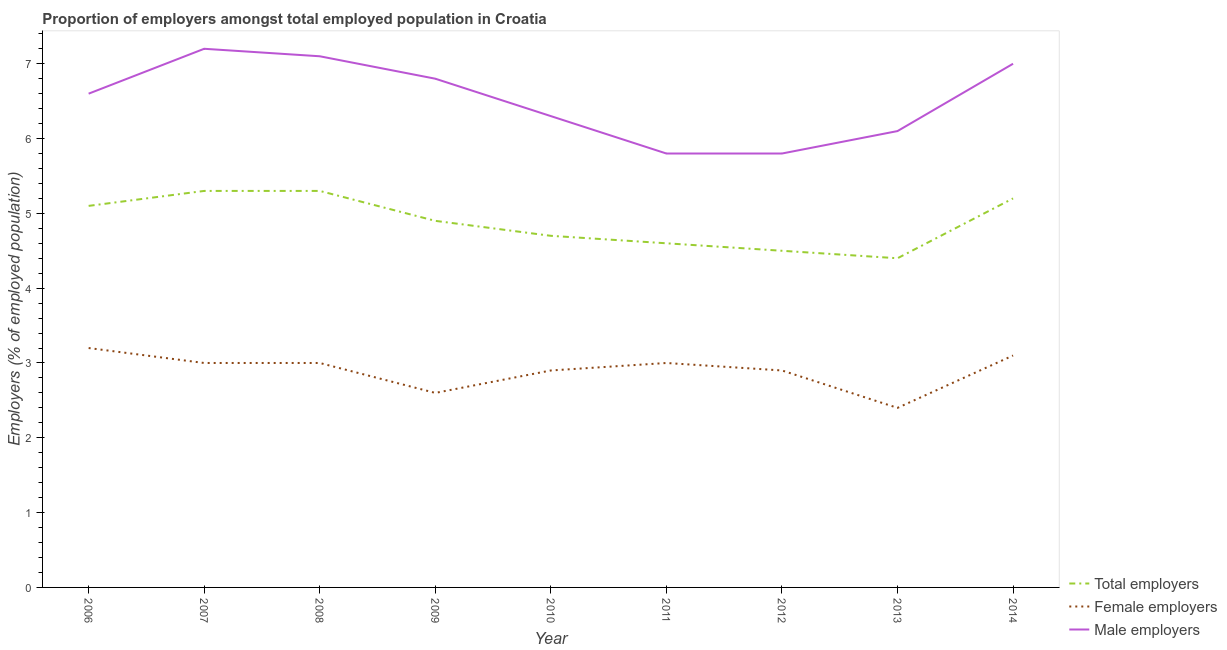How many different coloured lines are there?
Provide a short and direct response. 3. What is the percentage of male employers in 2014?
Make the answer very short. 7. Across all years, what is the maximum percentage of male employers?
Offer a terse response. 7.2. Across all years, what is the minimum percentage of total employers?
Your response must be concise. 4.4. In which year was the percentage of total employers minimum?
Offer a very short reply. 2013. What is the total percentage of total employers in the graph?
Your answer should be compact. 44. What is the difference between the percentage of female employers in 2009 and that in 2012?
Give a very brief answer. -0.3. What is the difference between the percentage of female employers in 2010 and the percentage of total employers in 2008?
Keep it short and to the point. -2.4. What is the average percentage of female employers per year?
Offer a terse response. 2.9. In the year 2007, what is the difference between the percentage of male employers and percentage of female employers?
Ensure brevity in your answer.  4.2. In how many years, is the percentage of female employers greater than 3.2 %?
Ensure brevity in your answer.  1. What is the ratio of the percentage of male employers in 2008 to that in 2012?
Your answer should be compact. 1.22. Is the difference between the percentage of female employers in 2008 and 2010 greater than the difference between the percentage of total employers in 2008 and 2010?
Make the answer very short. No. What is the difference between the highest and the second highest percentage of male employers?
Provide a short and direct response. 0.1. What is the difference between the highest and the lowest percentage of total employers?
Provide a succinct answer. 0.9. Is the sum of the percentage of total employers in 2009 and 2011 greater than the maximum percentage of male employers across all years?
Your response must be concise. Yes. Does the percentage of female employers monotonically increase over the years?
Your answer should be compact. No. Is the percentage of male employers strictly less than the percentage of total employers over the years?
Ensure brevity in your answer.  No. What is the difference between two consecutive major ticks on the Y-axis?
Your answer should be compact. 1. Are the values on the major ticks of Y-axis written in scientific E-notation?
Offer a very short reply. No. How many legend labels are there?
Ensure brevity in your answer.  3. How are the legend labels stacked?
Offer a very short reply. Vertical. What is the title of the graph?
Provide a short and direct response. Proportion of employers amongst total employed population in Croatia. Does "Machinery" appear as one of the legend labels in the graph?
Your response must be concise. No. What is the label or title of the Y-axis?
Give a very brief answer. Employers (% of employed population). What is the Employers (% of employed population) of Total employers in 2006?
Your answer should be compact. 5.1. What is the Employers (% of employed population) in Female employers in 2006?
Your response must be concise. 3.2. What is the Employers (% of employed population) of Male employers in 2006?
Make the answer very short. 6.6. What is the Employers (% of employed population) of Total employers in 2007?
Keep it short and to the point. 5.3. What is the Employers (% of employed population) in Female employers in 2007?
Your answer should be very brief. 3. What is the Employers (% of employed population) of Male employers in 2007?
Offer a very short reply. 7.2. What is the Employers (% of employed population) of Total employers in 2008?
Provide a short and direct response. 5.3. What is the Employers (% of employed population) in Female employers in 2008?
Your answer should be very brief. 3. What is the Employers (% of employed population) of Male employers in 2008?
Your answer should be very brief. 7.1. What is the Employers (% of employed population) of Total employers in 2009?
Provide a short and direct response. 4.9. What is the Employers (% of employed population) of Female employers in 2009?
Offer a terse response. 2.6. What is the Employers (% of employed population) of Male employers in 2009?
Provide a short and direct response. 6.8. What is the Employers (% of employed population) in Total employers in 2010?
Offer a very short reply. 4.7. What is the Employers (% of employed population) of Female employers in 2010?
Offer a very short reply. 2.9. What is the Employers (% of employed population) in Male employers in 2010?
Give a very brief answer. 6.3. What is the Employers (% of employed population) in Total employers in 2011?
Your response must be concise. 4.6. What is the Employers (% of employed population) of Female employers in 2011?
Offer a terse response. 3. What is the Employers (% of employed population) of Male employers in 2011?
Your answer should be very brief. 5.8. What is the Employers (% of employed population) of Total employers in 2012?
Make the answer very short. 4.5. What is the Employers (% of employed population) in Female employers in 2012?
Your answer should be very brief. 2.9. What is the Employers (% of employed population) in Male employers in 2012?
Provide a succinct answer. 5.8. What is the Employers (% of employed population) of Total employers in 2013?
Ensure brevity in your answer.  4.4. What is the Employers (% of employed population) in Female employers in 2013?
Provide a succinct answer. 2.4. What is the Employers (% of employed population) of Male employers in 2013?
Your response must be concise. 6.1. What is the Employers (% of employed population) of Total employers in 2014?
Keep it short and to the point. 5.2. What is the Employers (% of employed population) in Female employers in 2014?
Make the answer very short. 3.1. What is the Employers (% of employed population) in Male employers in 2014?
Keep it short and to the point. 7. Across all years, what is the maximum Employers (% of employed population) of Total employers?
Offer a terse response. 5.3. Across all years, what is the maximum Employers (% of employed population) of Female employers?
Keep it short and to the point. 3.2. Across all years, what is the maximum Employers (% of employed population) of Male employers?
Provide a short and direct response. 7.2. Across all years, what is the minimum Employers (% of employed population) in Total employers?
Provide a succinct answer. 4.4. Across all years, what is the minimum Employers (% of employed population) of Female employers?
Offer a terse response. 2.4. Across all years, what is the minimum Employers (% of employed population) in Male employers?
Keep it short and to the point. 5.8. What is the total Employers (% of employed population) of Female employers in the graph?
Make the answer very short. 26.1. What is the total Employers (% of employed population) in Male employers in the graph?
Your response must be concise. 58.7. What is the difference between the Employers (% of employed population) in Female employers in 2006 and that in 2007?
Make the answer very short. 0.2. What is the difference between the Employers (% of employed population) in Male employers in 2006 and that in 2007?
Make the answer very short. -0.6. What is the difference between the Employers (% of employed population) of Total employers in 2006 and that in 2008?
Make the answer very short. -0.2. What is the difference between the Employers (% of employed population) of Male employers in 2006 and that in 2008?
Offer a very short reply. -0.5. What is the difference between the Employers (% of employed population) of Total employers in 2006 and that in 2009?
Give a very brief answer. 0.2. What is the difference between the Employers (% of employed population) in Total employers in 2006 and that in 2010?
Provide a short and direct response. 0.4. What is the difference between the Employers (% of employed population) of Female employers in 2006 and that in 2010?
Keep it short and to the point. 0.3. What is the difference between the Employers (% of employed population) in Total employers in 2006 and that in 2011?
Provide a short and direct response. 0.5. What is the difference between the Employers (% of employed population) in Total employers in 2006 and that in 2013?
Ensure brevity in your answer.  0.7. What is the difference between the Employers (% of employed population) of Female employers in 2006 and that in 2013?
Your response must be concise. 0.8. What is the difference between the Employers (% of employed population) of Male employers in 2006 and that in 2013?
Your answer should be compact. 0.5. What is the difference between the Employers (% of employed population) of Male employers in 2006 and that in 2014?
Offer a terse response. -0.4. What is the difference between the Employers (% of employed population) in Female employers in 2007 and that in 2008?
Give a very brief answer. 0. What is the difference between the Employers (% of employed population) of Male employers in 2007 and that in 2008?
Provide a succinct answer. 0.1. What is the difference between the Employers (% of employed population) of Male employers in 2007 and that in 2009?
Ensure brevity in your answer.  0.4. What is the difference between the Employers (% of employed population) of Female employers in 2007 and that in 2010?
Your answer should be compact. 0.1. What is the difference between the Employers (% of employed population) of Total employers in 2007 and that in 2011?
Give a very brief answer. 0.7. What is the difference between the Employers (% of employed population) in Female employers in 2007 and that in 2011?
Your response must be concise. 0. What is the difference between the Employers (% of employed population) of Female employers in 2007 and that in 2012?
Give a very brief answer. 0.1. What is the difference between the Employers (% of employed population) of Total employers in 2007 and that in 2013?
Your answer should be very brief. 0.9. What is the difference between the Employers (% of employed population) of Total employers in 2007 and that in 2014?
Ensure brevity in your answer.  0.1. What is the difference between the Employers (% of employed population) in Male employers in 2007 and that in 2014?
Make the answer very short. 0.2. What is the difference between the Employers (% of employed population) of Total employers in 2008 and that in 2010?
Your answer should be compact. 0.6. What is the difference between the Employers (% of employed population) of Female employers in 2008 and that in 2010?
Offer a very short reply. 0.1. What is the difference between the Employers (% of employed population) of Female employers in 2008 and that in 2011?
Provide a succinct answer. 0. What is the difference between the Employers (% of employed population) in Total employers in 2008 and that in 2012?
Give a very brief answer. 0.8. What is the difference between the Employers (% of employed population) of Female employers in 2008 and that in 2012?
Keep it short and to the point. 0.1. What is the difference between the Employers (% of employed population) of Total employers in 2008 and that in 2013?
Offer a terse response. 0.9. What is the difference between the Employers (% of employed population) in Female employers in 2008 and that in 2013?
Give a very brief answer. 0.6. What is the difference between the Employers (% of employed population) in Male employers in 2008 and that in 2013?
Your answer should be very brief. 1. What is the difference between the Employers (% of employed population) in Total employers in 2008 and that in 2014?
Make the answer very short. 0.1. What is the difference between the Employers (% of employed population) of Total employers in 2009 and that in 2010?
Keep it short and to the point. 0.2. What is the difference between the Employers (% of employed population) of Male employers in 2009 and that in 2010?
Your answer should be compact. 0.5. What is the difference between the Employers (% of employed population) in Total employers in 2009 and that in 2011?
Ensure brevity in your answer.  0.3. What is the difference between the Employers (% of employed population) of Total employers in 2009 and that in 2012?
Provide a short and direct response. 0.4. What is the difference between the Employers (% of employed population) of Female employers in 2009 and that in 2012?
Ensure brevity in your answer.  -0.3. What is the difference between the Employers (% of employed population) of Female employers in 2009 and that in 2013?
Your response must be concise. 0.2. What is the difference between the Employers (% of employed population) in Total employers in 2009 and that in 2014?
Your response must be concise. -0.3. What is the difference between the Employers (% of employed population) of Female employers in 2009 and that in 2014?
Offer a terse response. -0.5. What is the difference between the Employers (% of employed population) of Male employers in 2009 and that in 2014?
Ensure brevity in your answer.  -0.2. What is the difference between the Employers (% of employed population) in Total employers in 2010 and that in 2011?
Provide a succinct answer. 0.1. What is the difference between the Employers (% of employed population) in Female employers in 2010 and that in 2011?
Provide a succinct answer. -0.1. What is the difference between the Employers (% of employed population) in Female employers in 2010 and that in 2012?
Your answer should be very brief. 0. What is the difference between the Employers (% of employed population) in Male employers in 2010 and that in 2012?
Ensure brevity in your answer.  0.5. What is the difference between the Employers (% of employed population) in Total employers in 2010 and that in 2014?
Your answer should be very brief. -0.5. What is the difference between the Employers (% of employed population) of Male employers in 2011 and that in 2014?
Your response must be concise. -1.2. What is the difference between the Employers (% of employed population) in Total employers in 2012 and that in 2013?
Offer a very short reply. 0.1. What is the difference between the Employers (% of employed population) in Female employers in 2012 and that in 2013?
Your answer should be compact. 0.5. What is the difference between the Employers (% of employed population) of Male employers in 2013 and that in 2014?
Offer a terse response. -0.9. What is the difference between the Employers (% of employed population) in Total employers in 2006 and the Employers (% of employed population) in Female employers in 2007?
Provide a succinct answer. 2.1. What is the difference between the Employers (% of employed population) of Total employers in 2006 and the Employers (% of employed population) of Male employers in 2007?
Your answer should be compact. -2.1. What is the difference between the Employers (% of employed population) in Female employers in 2006 and the Employers (% of employed population) in Male employers in 2007?
Offer a terse response. -4. What is the difference between the Employers (% of employed population) of Total employers in 2006 and the Employers (% of employed population) of Female employers in 2008?
Your answer should be very brief. 2.1. What is the difference between the Employers (% of employed population) of Total employers in 2006 and the Employers (% of employed population) of Male employers in 2008?
Give a very brief answer. -2. What is the difference between the Employers (% of employed population) of Total employers in 2006 and the Employers (% of employed population) of Female employers in 2009?
Make the answer very short. 2.5. What is the difference between the Employers (% of employed population) in Total employers in 2006 and the Employers (% of employed population) in Female employers in 2010?
Make the answer very short. 2.2. What is the difference between the Employers (% of employed population) in Female employers in 2006 and the Employers (% of employed population) in Male employers in 2011?
Keep it short and to the point. -2.6. What is the difference between the Employers (% of employed population) of Total employers in 2006 and the Employers (% of employed population) of Female employers in 2012?
Your response must be concise. 2.2. What is the difference between the Employers (% of employed population) in Total employers in 2006 and the Employers (% of employed population) in Female employers in 2013?
Your answer should be very brief. 2.7. What is the difference between the Employers (% of employed population) of Female employers in 2006 and the Employers (% of employed population) of Male employers in 2013?
Your answer should be very brief. -2.9. What is the difference between the Employers (% of employed population) of Total employers in 2006 and the Employers (% of employed population) of Female employers in 2014?
Offer a terse response. 2. What is the difference between the Employers (% of employed population) of Total employers in 2006 and the Employers (% of employed population) of Male employers in 2014?
Ensure brevity in your answer.  -1.9. What is the difference between the Employers (% of employed population) in Total employers in 2007 and the Employers (% of employed population) in Male employers in 2008?
Offer a terse response. -1.8. What is the difference between the Employers (% of employed population) of Female employers in 2007 and the Employers (% of employed population) of Male employers in 2008?
Make the answer very short. -4.1. What is the difference between the Employers (% of employed population) in Total employers in 2007 and the Employers (% of employed population) in Male employers in 2009?
Offer a terse response. -1.5. What is the difference between the Employers (% of employed population) of Total employers in 2007 and the Employers (% of employed population) of Female employers in 2011?
Offer a terse response. 2.3. What is the difference between the Employers (% of employed population) in Female employers in 2007 and the Employers (% of employed population) in Male employers in 2011?
Ensure brevity in your answer.  -2.8. What is the difference between the Employers (% of employed population) of Female employers in 2007 and the Employers (% of employed population) of Male employers in 2012?
Give a very brief answer. -2.8. What is the difference between the Employers (% of employed population) in Total employers in 2007 and the Employers (% of employed population) in Female employers in 2013?
Your answer should be compact. 2.9. What is the difference between the Employers (% of employed population) of Total employers in 2007 and the Employers (% of employed population) of Male employers in 2014?
Your answer should be compact. -1.7. What is the difference between the Employers (% of employed population) of Female employers in 2007 and the Employers (% of employed population) of Male employers in 2014?
Keep it short and to the point. -4. What is the difference between the Employers (% of employed population) in Female employers in 2008 and the Employers (% of employed population) in Male employers in 2009?
Ensure brevity in your answer.  -3.8. What is the difference between the Employers (% of employed population) in Total employers in 2008 and the Employers (% of employed population) in Female employers in 2010?
Your answer should be compact. 2.4. What is the difference between the Employers (% of employed population) in Female employers in 2008 and the Employers (% of employed population) in Male employers in 2010?
Provide a succinct answer. -3.3. What is the difference between the Employers (% of employed population) of Total employers in 2008 and the Employers (% of employed population) of Female employers in 2011?
Provide a short and direct response. 2.3. What is the difference between the Employers (% of employed population) in Total employers in 2008 and the Employers (% of employed population) in Female employers in 2012?
Offer a very short reply. 2.4. What is the difference between the Employers (% of employed population) of Total employers in 2008 and the Employers (% of employed population) of Female employers in 2013?
Offer a very short reply. 2.9. What is the difference between the Employers (% of employed population) of Total employers in 2008 and the Employers (% of employed population) of Male employers in 2013?
Offer a terse response. -0.8. What is the difference between the Employers (% of employed population) of Female employers in 2008 and the Employers (% of employed population) of Male employers in 2013?
Ensure brevity in your answer.  -3.1. What is the difference between the Employers (% of employed population) in Total employers in 2008 and the Employers (% of employed population) in Male employers in 2014?
Provide a succinct answer. -1.7. What is the difference between the Employers (% of employed population) in Female employers in 2008 and the Employers (% of employed population) in Male employers in 2014?
Make the answer very short. -4. What is the difference between the Employers (% of employed population) of Female employers in 2009 and the Employers (% of employed population) of Male employers in 2010?
Give a very brief answer. -3.7. What is the difference between the Employers (% of employed population) in Total employers in 2009 and the Employers (% of employed population) in Female employers in 2011?
Give a very brief answer. 1.9. What is the difference between the Employers (% of employed population) in Female employers in 2009 and the Employers (% of employed population) in Male employers in 2011?
Your answer should be very brief. -3.2. What is the difference between the Employers (% of employed population) of Total employers in 2009 and the Employers (% of employed population) of Male employers in 2012?
Ensure brevity in your answer.  -0.9. What is the difference between the Employers (% of employed population) of Female employers in 2009 and the Employers (% of employed population) of Male employers in 2012?
Keep it short and to the point. -3.2. What is the difference between the Employers (% of employed population) of Total employers in 2009 and the Employers (% of employed population) of Female employers in 2013?
Keep it short and to the point. 2.5. What is the difference between the Employers (% of employed population) of Female employers in 2009 and the Employers (% of employed population) of Male employers in 2013?
Provide a succinct answer. -3.5. What is the difference between the Employers (% of employed population) of Total employers in 2009 and the Employers (% of employed population) of Male employers in 2014?
Provide a succinct answer. -2.1. What is the difference between the Employers (% of employed population) in Female employers in 2010 and the Employers (% of employed population) in Male employers in 2011?
Your response must be concise. -2.9. What is the difference between the Employers (% of employed population) of Total employers in 2010 and the Employers (% of employed population) of Male employers in 2012?
Your response must be concise. -1.1. What is the difference between the Employers (% of employed population) of Female employers in 2010 and the Employers (% of employed population) of Male employers in 2012?
Provide a short and direct response. -2.9. What is the difference between the Employers (% of employed population) in Total employers in 2010 and the Employers (% of employed population) in Female employers in 2013?
Offer a terse response. 2.3. What is the difference between the Employers (% of employed population) of Total employers in 2010 and the Employers (% of employed population) of Female employers in 2014?
Give a very brief answer. 1.6. What is the difference between the Employers (% of employed population) in Female employers in 2010 and the Employers (% of employed population) in Male employers in 2014?
Make the answer very short. -4.1. What is the difference between the Employers (% of employed population) in Total employers in 2011 and the Employers (% of employed population) in Female employers in 2012?
Provide a succinct answer. 1.7. What is the difference between the Employers (% of employed population) of Female employers in 2011 and the Employers (% of employed population) of Male employers in 2012?
Keep it short and to the point. -2.8. What is the difference between the Employers (% of employed population) in Total employers in 2011 and the Employers (% of employed population) in Female employers in 2013?
Offer a terse response. 2.2. What is the difference between the Employers (% of employed population) in Female employers in 2011 and the Employers (% of employed population) in Male employers in 2013?
Offer a terse response. -3.1. What is the difference between the Employers (% of employed population) in Female employers in 2011 and the Employers (% of employed population) in Male employers in 2014?
Give a very brief answer. -4. What is the difference between the Employers (% of employed population) in Total employers in 2012 and the Employers (% of employed population) in Male employers in 2013?
Provide a succinct answer. -1.6. What is the difference between the Employers (% of employed population) in Female employers in 2012 and the Employers (% of employed population) in Male employers in 2013?
Provide a short and direct response. -3.2. What is the difference between the Employers (% of employed population) of Total employers in 2012 and the Employers (% of employed population) of Female employers in 2014?
Your answer should be compact. 1.4. What is the difference between the Employers (% of employed population) of Total employers in 2012 and the Employers (% of employed population) of Male employers in 2014?
Your answer should be compact. -2.5. What is the difference between the Employers (% of employed population) in Total employers in 2013 and the Employers (% of employed population) in Male employers in 2014?
Offer a very short reply. -2.6. What is the average Employers (% of employed population) of Total employers per year?
Your answer should be very brief. 4.89. What is the average Employers (% of employed population) in Male employers per year?
Offer a very short reply. 6.52. In the year 2007, what is the difference between the Employers (% of employed population) in Total employers and Employers (% of employed population) in Female employers?
Your answer should be compact. 2.3. In the year 2007, what is the difference between the Employers (% of employed population) of Total employers and Employers (% of employed population) of Male employers?
Give a very brief answer. -1.9. In the year 2007, what is the difference between the Employers (% of employed population) of Female employers and Employers (% of employed population) of Male employers?
Provide a succinct answer. -4.2. In the year 2009, what is the difference between the Employers (% of employed population) of Total employers and Employers (% of employed population) of Female employers?
Offer a very short reply. 2.3. In the year 2010, what is the difference between the Employers (% of employed population) in Total employers and Employers (% of employed population) in Female employers?
Make the answer very short. 1.8. In the year 2010, what is the difference between the Employers (% of employed population) in Total employers and Employers (% of employed population) in Male employers?
Ensure brevity in your answer.  -1.6. In the year 2011, what is the difference between the Employers (% of employed population) of Total employers and Employers (% of employed population) of Male employers?
Keep it short and to the point. -1.2. In the year 2013, what is the difference between the Employers (% of employed population) of Total employers and Employers (% of employed population) of Female employers?
Your answer should be compact. 2. In the year 2013, what is the difference between the Employers (% of employed population) in Total employers and Employers (% of employed population) in Male employers?
Offer a very short reply. -1.7. In the year 2014, what is the difference between the Employers (% of employed population) of Total employers and Employers (% of employed population) of Male employers?
Your answer should be very brief. -1.8. In the year 2014, what is the difference between the Employers (% of employed population) of Female employers and Employers (% of employed population) of Male employers?
Provide a succinct answer. -3.9. What is the ratio of the Employers (% of employed population) in Total employers in 2006 to that in 2007?
Provide a short and direct response. 0.96. What is the ratio of the Employers (% of employed population) of Female employers in 2006 to that in 2007?
Make the answer very short. 1.07. What is the ratio of the Employers (% of employed population) in Total employers in 2006 to that in 2008?
Offer a terse response. 0.96. What is the ratio of the Employers (% of employed population) of Female employers in 2006 to that in 2008?
Ensure brevity in your answer.  1.07. What is the ratio of the Employers (% of employed population) in Male employers in 2006 to that in 2008?
Your response must be concise. 0.93. What is the ratio of the Employers (% of employed population) in Total employers in 2006 to that in 2009?
Ensure brevity in your answer.  1.04. What is the ratio of the Employers (% of employed population) in Female employers in 2006 to that in 2009?
Give a very brief answer. 1.23. What is the ratio of the Employers (% of employed population) in Male employers in 2006 to that in 2009?
Your answer should be very brief. 0.97. What is the ratio of the Employers (% of employed population) of Total employers in 2006 to that in 2010?
Offer a terse response. 1.09. What is the ratio of the Employers (% of employed population) of Female employers in 2006 to that in 2010?
Provide a succinct answer. 1.1. What is the ratio of the Employers (% of employed population) of Male employers in 2006 to that in 2010?
Make the answer very short. 1.05. What is the ratio of the Employers (% of employed population) of Total employers in 2006 to that in 2011?
Provide a short and direct response. 1.11. What is the ratio of the Employers (% of employed population) in Female employers in 2006 to that in 2011?
Give a very brief answer. 1.07. What is the ratio of the Employers (% of employed population) in Male employers in 2006 to that in 2011?
Provide a short and direct response. 1.14. What is the ratio of the Employers (% of employed population) in Total employers in 2006 to that in 2012?
Ensure brevity in your answer.  1.13. What is the ratio of the Employers (% of employed population) in Female employers in 2006 to that in 2012?
Make the answer very short. 1.1. What is the ratio of the Employers (% of employed population) of Male employers in 2006 to that in 2012?
Ensure brevity in your answer.  1.14. What is the ratio of the Employers (% of employed population) of Total employers in 2006 to that in 2013?
Offer a very short reply. 1.16. What is the ratio of the Employers (% of employed population) in Male employers in 2006 to that in 2013?
Make the answer very short. 1.08. What is the ratio of the Employers (% of employed population) in Total employers in 2006 to that in 2014?
Keep it short and to the point. 0.98. What is the ratio of the Employers (% of employed population) in Female employers in 2006 to that in 2014?
Your answer should be very brief. 1.03. What is the ratio of the Employers (% of employed population) in Male employers in 2006 to that in 2014?
Your answer should be very brief. 0.94. What is the ratio of the Employers (% of employed population) of Total employers in 2007 to that in 2008?
Your answer should be compact. 1. What is the ratio of the Employers (% of employed population) in Female employers in 2007 to that in 2008?
Your response must be concise. 1. What is the ratio of the Employers (% of employed population) in Male employers in 2007 to that in 2008?
Ensure brevity in your answer.  1.01. What is the ratio of the Employers (% of employed population) in Total employers in 2007 to that in 2009?
Offer a very short reply. 1.08. What is the ratio of the Employers (% of employed population) of Female employers in 2007 to that in 2009?
Provide a succinct answer. 1.15. What is the ratio of the Employers (% of employed population) in Male employers in 2007 to that in 2009?
Your answer should be compact. 1.06. What is the ratio of the Employers (% of employed population) of Total employers in 2007 to that in 2010?
Keep it short and to the point. 1.13. What is the ratio of the Employers (% of employed population) of Female employers in 2007 to that in 2010?
Your response must be concise. 1.03. What is the ratio of the Employers (% of employed population) in Male employers in 2007 to that in 2010?
Offer a very short reply. 1.14. What is the ratio of the Employers (% of employed population) in Total employers in 2007 to that in 2011?
Your answer should be very brief. 1.15. What is the ratio of the Employers (% of employed population) of Female employers in 2007 to that in 2011?
Keep it short and to the point. 1. What is the ratio of the Employers (% of employed population) of Male employers in 2007 to that in 2011?
Provide a succinct answer. 1.24. What is the ratio of the Employers (% of employed population) of Total employers in 2007 to that in 2012?
Provide a succinct answer. 1.18. What is the ratio of the Employers (% of employed population) in Female employers in 2007 to that in 2012?
Make the answer very short. 1.03. What is the ratio of the Employers (% of employed population) of Male employers in 2007 to that in 2012?
Provide a succinct answer. 1.24. What is the ratio of the Employers (% of employed population) of Total employers in 2007 to that in 2013?
Provide a short and direct response. 1.2. What is the ratio of the Employers (% of employed population) in Male employers in 2007 to that in 2013?
Keep it short and to the point. 1.18. What is the ratio of the Employers (% of employed population) of Total employers in 2007 to that in 2014?
Provide a short and direct response. 1.02. What is the ratio of the Employers (% of employed population) in Female employers in 2007 to that in 2014?
Offer a terse response. 0.97. What is the ratio of the Employers (% of employed population) in Male employers in 2007 to that in 2014?
Your answer should be very brief. 1.03. What is the ratio of the Employers (% of employed population) of Total employers in 2008 to that in 2009?
Ensure brevity in your answer.  1.08. What is the ratio of the Employers (% of employed population) of Female employers in 2008 to that in 2009?
Your response must be concise. 1.15. What is the ratio of the Employers (% of employed population) in Male employers in 2008 to that in 2009?
Keep it short and to the point. 1.04. What is the ratio of the Employers (% of employed population) in Total employers in 2008 to that in 2010?
Offer a terse response. 1.13. What is the ratio of the Employers (% of employed population) of Female employers in 2008 to that in 2010?
Make the answer very short. 1.03. What is the ratio of the Employers (% of employed population) in Male employers in 2008 to that in 2010?
Offer a terse response. 1.13. What is the ratio of the Employers (% of employed population) in Total employers in 2008 to that in 2011?
Your response must be concise. 1.15. What is the ratio of the Employers (% of employed population) in Female employers in 2008 to that in 2011?
Give a very brief answer. 1. What is the ratio of the Employers (% of employed population) of Male employers in 2008 to that in 2011?
Ensure brevity in your answer.  1.22. What is the ratio of the Employers (% of employed population) of Total employers in 2008 to that in 2012?
Provide a short and direct response. 1.18. What is the ratio of the Employers (% of employed population) of Female employers in 2008 to that in 2012?
Your answer should be very brief. 1.03. What is the ratio of the Employers (% of employed population) of Male employers in 2008 to that in 2012?
Give a very brief answer. 1.22. What is the ratio of the Employers (% of employed population) of Total employers in 2008 to that in 2013?
Keep it short and to the point. 1.2. What is the ratio of the Employers (% of employed population) in Female employers in 2008 to that in 2013?
Make the answer very short. 1.25. What is the ratio of the Employers (% of employed population) of Male employers in 2008 to that in 2013?
Your answer should be very brief. 1.16. What is the ratio of the Employers (% of employed population) of Total employers in 2008 to that in 2014?
Ensure brevity in your answer.  1.02. What is the ratio of the Employers (% of employed population) in Male employers in 2008 to that in 2014?
Your answer should be very brief. 1.01. What is the ratio of the Employers (% of employed population) of Total employers in 2009 to that in 2010?
Ensure brevity in your answer.  1.04. What is the ratio of the Employers (% of employed population) of Female employers in 2009 to that in 2010?
Your response must be concise. 0.9. What is the ratio of the Employers (% of employed population) in Male employers in 2009 to that in 2010?
Give a very brief answer. 1.08. What is the ratio of the Employers (% of employed population) in Total employers in 2009 to that in 2011?
Ensure brevity in your answer.  1.07. What is the ratio of the Employers (% of employed population) of Female employers in 2009 to that in 2011?
Make the answer very short. 0.87. What is the ratio of the Employers (% of employed population) in Male employers in 2009 to that in 2011?
Provide a succinct answer. 1.17. What is the ratio of the Employers (% of employed population) of Total employers in 2009 to that in 2012?
Offer a terse response. 1.09. What is the ratio of the Employers (% of employed population) of Female employers in 2009 to that in 2012?
Give a very brief answer. 0.9. What is the ratio of the Employers (% of employed population) of Male employers in 2009 to that in 2012?
Provide a short and direct response. 1.17. What is the ratio of the Employers (% of employed population) of Total employers in 2009 to that in 2013?
Offer a very short reply. 1.11. What is the ratio of the Employers (% of employed population) of Female employers in 2009 to that in 2013?
Ensure brevity in your answer.  1.08. What is the ratio of the Employers (% of employed population) of Male employers in 2009 to that in 2013?
Your answer should be compact. 1.11. What is the ratio of the Employers (% of employed population) of Total employers in 2009 to that in 2014?
Your answer should be compact. 0.94. What is the ratio of the Employers (% of employed population) in Female employers in 2009 to that in 2014?
Your answer should be compact. 0.84. What is the ratio of the Employers (% of employed population) in Male employers in 2009 to that in 2014?
Ensure brevity in your answer.  0.97. What is the ratio of the Employers (% of employed population) in Total employers in 2010 to that in 2011?
Your response must be concise. 1.02. What is the ratio of the Employers (% of employed population) in Female employers in 2010 to that in 2011?
Give a very brief answer. 0.97. What is the ratio of the Employers (% of employed population) in Male employers in 2010 to that in 2011?
Give a very brief answer. 1.09. What is the ratio of the Employers (% of employed population) in Total employers in 2010 to that in 2012?
Offer a terse response. 1.04. What is the ratio of the Employers (% of employed population) in Male employers in 2010 to that in 2012?
Give a very brief answer. 1.09. What is the ratio of the Employers (% of employed population) in Total employers in 2010 to that in 2013?
Your answer should be very brief. 1.07. What is the ratio of the Employers (% of employed population) of Female employers in 2010 to that in 2013?
Provide a short and direct response. 1.21. What is the ratio of the Employers (% of employed population) of Male employers in 2010 to that in 2013?
Your response must be concise. 1.03. What is the ratio of the Employers (% of employed population) of Total employers in 2010 to that in 2014?
Offer a very short reply. 0.9. What is the ratio of the Employers (% of employed population) of Female employers in 2010 to that in 2014?
Offer a terse response. 0.94. What is the ratio of the Employers (% of employed population) of Total employers in 2011 to that in 2012?
Your answer should be very brief. 1.02. What is the ratio of the Employers (% of employed population) of Female employers in 2011 to that in 2012?
Provide a short and direct response. 1.03. What is the ratio of the Employers (% of employed population) in Total employers in 2011 to that in 2013?
Make the answer very short. 1.05. What is the ratio of the Employers (% of employed population) of Male employers in 2011 to that in 2013?
Keep it short and to the point. 0.95. What is the ratio of the Employers (% of employed population) in Total employers in 2011 to that in 2014?
Ensure brevity in your answer.  0.88. What is the ratio of the Employers (% of employed population) of Female employers in 2011 to that in 2014?
Offer a very short reply. 0.97. What is the ratio of the Employers (% of employed population) in Male employers in 2011 to that in 2014?
Offer a very short reply. 0.83. What is the ratio of the Employers (% of employed population) of Total employers in 2012 to that in 2013?
Make the answer very short. 1.02. What is the ratio of the Employers (% of employed population) in Female employers in 2012 to that in 2013?
Ensure brevity in your answer.  1.21. What is the ratio of the Employers (% of employed population) in Male employers in 2012 to that in 2013?
Provide a short and direct response. 0.95. What is the ratio of the Employers (% of employed population) in Total employers in 2012 to that in 2014?
Your answer should be compact. 0.87. What is the ratio of the Employers (% of employed population) of Female employers in 2012 to that in 2014?
Offer a terse response. 0.94. What is the ratio of the Employers (% of employed population) of Male employers in 2012 to that in 2014?
Your answer should be very brief. 0.83. What is the ratio of the Employers (% of employed population) of Total employers in 2013 to that in 2014?
Offer a terse response. 0.85. What is the ratio of the Employers (% of employed population) in Female employers in 2013 to that in 2014?
Your answer should be very brief. 0.77. What is the ratio of the Employers (% of employed population) in Male employers in 2013 to that in 2014?
Your response must be concise. 0.87. What is the difference between the highest and the second highest Employers (% of employed population) in Male employers?
Your response must be concise. 0.1. 